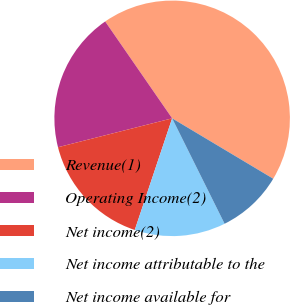<chart> <loc_0><loc_0><loc_500><loc_500><pie_chart><fcel>Revenue(1)<fcel>Operating Income(2)<fcel>Net income(2)<fcel>Net income attributable to the<fcel>Net income available for<nl><fcel>43.2%<fcel>19.32%<fcel>15.91%<fcel>12.49%<fcel>9.08%<nl></chart> 